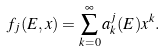Convert formula to latex. <formula><loc_0><loc_0><loc_500><loc_500>f _ { j } ( E , x ) & = \sum _ { k = 0 } ^ { \infty } a _ { k } ^ { j } ( E ) x ^ { k } .</formula> 